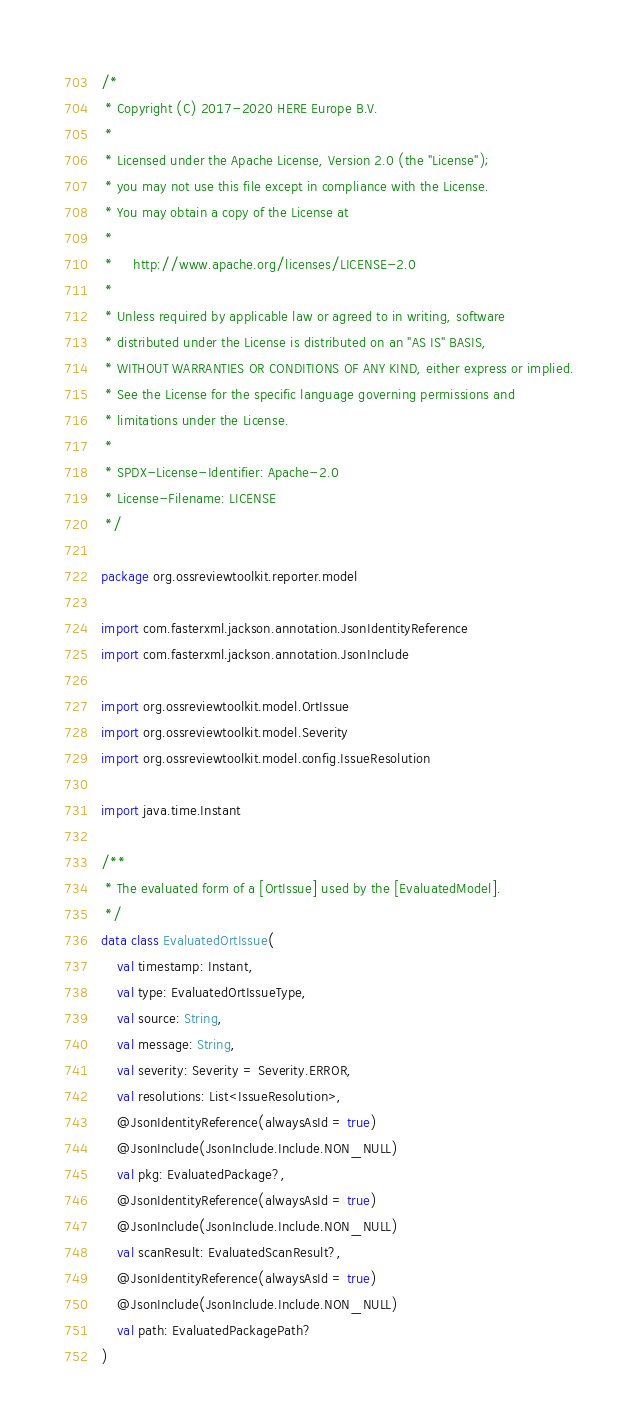Convert code to text. <code><loc_0><loc_0><loc_500><loc_500><_Kotlin_>/*
 * Copyright (C) 2017-2020 HERE Europe B.V.
 *
 * Licensed under the Apache License, Version 2.0 (the "License");
 * you may not use this file except in compliance with the License.
 * You may obtain a copy of the License at
 *
 *     http://www.apache.org/licenses/LICENSE-2.0
 *
 * Unless required by applicable law or agreed to in writing, software
 * distributed under the License is distributed on an "AS IS" BASIS,
 * WITHOUT WARRANTIES OR CONDITIONS OF ANY KIND, either express or implied.
 * See the License for the specific language governing permissions and
 * limitations under the License.
 *
 * SPDX-License-Identifier: Apache-2.0
 * License-Filename: LICENSE
 */

package org.ossreviewtoolkit.reporter.model

import com.fasterxml.jackson.annotation.JsonIdentityReference
import com.fasterxml.jackson.annotation.JsonInclude

import org.ossreviewtoolkit.model.OrtIssue
import org.ossreviewtoolkit.model.Severity
import org.ossreviewtoolkit.model.config.IssueResolution

import java.time.Instant

/**
 * The evaluated form of a [OrtIssue] used by the [EvaluatedModel].
 */
data class EvaluatedOrtIssue(
    val timestamp: Instant,
    val type: EvaluatedOrtIssueType,
    val source: String,
    val message: String,
    val severity: Severity = Severity.ERROR,
    val resolutions: List<IssueResolution>,
    @JsonIdentityReference(alwaysAsId = true)
    @JsonInclude(JsonInclude.Include.NON_NULL)
    val pkg: EvaluatedPackage?,
    @JsonIdentityReference(alwaysAsId = true)
    @JsonInclude(JsonInclude.Include.NON_NULL)
    val scanResult: EvaluatedScanResult?,
    @JsonIdentityReference(alwaysAsId = true)
    @JsonInclude(JsonInclude.Include.NON_NULL)
    val path: EvaluatedPackagePath?
)
</code> 